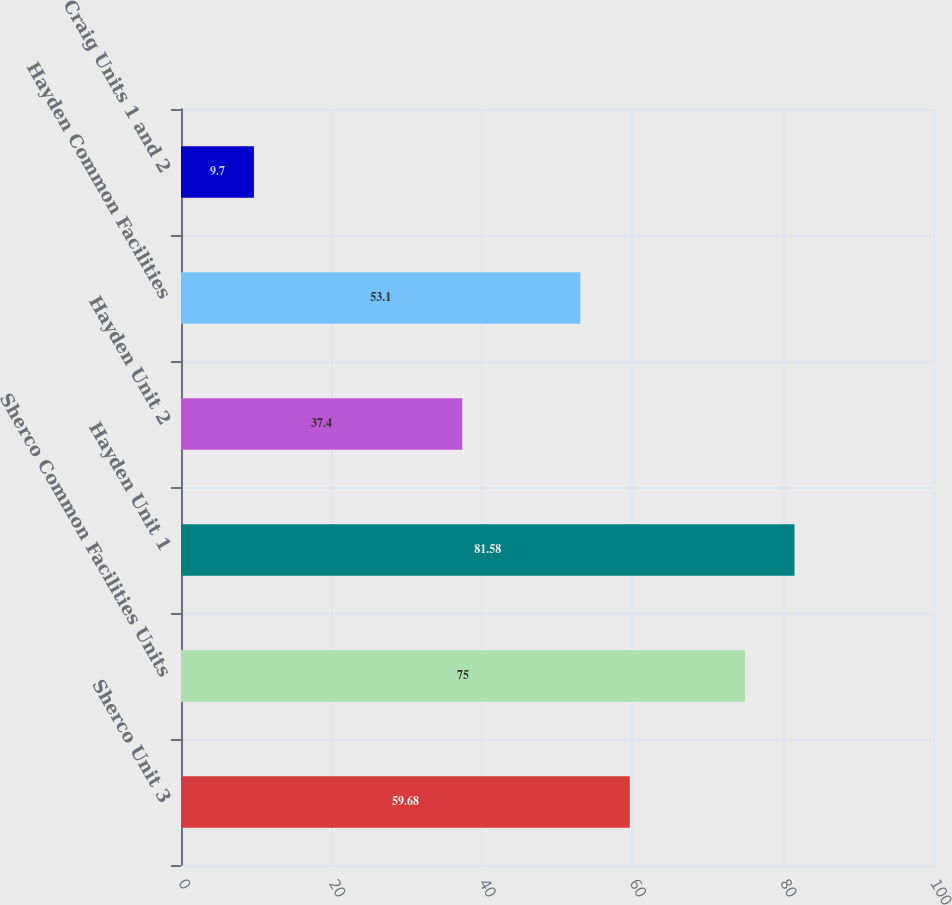<chart> <loc_0><loc_0><loc_500><loc_500><bar_chart><fcel>Sherco Unit 3<fcel>Sherco Common Facilities Units<fcel>Hayden Unit 1<fcel>Hayden Unit 2<fcel>Hayden Common Facilities<fcel>Craig Units 1 and 2<nl><fcel>59.68<fcel>75<fcel>81.58<fcel>37.4<fcel>53.1<fcel>9.7<nl></chart> 